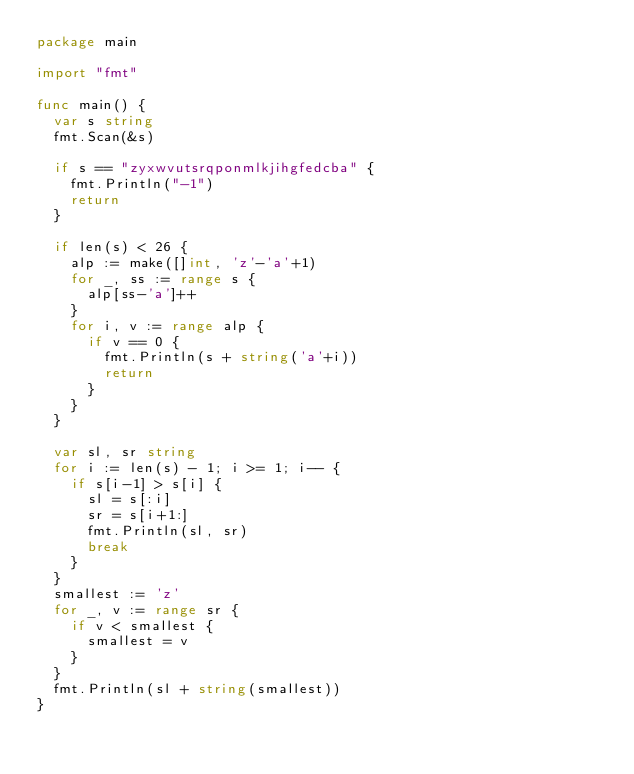Convert code to text. <code><loc_0><loc_0><loc_500><loc_500><_Go_>package main

import "fmt"

func main() {
	var s string
	fmt.Scan(&s)

	if s == "zyxwvutsrqponmlkjihgfedcba" {
		fmt.Println("-1")
		return
	}

	if len(s) < 26 {
		alp := make([]int, 'z'-'a'+1)
		for _, ss := range s {
			alp[ss-'a']++
		}
		for i, v := range alp {
			if v == 0 {
				fmt.Println(s + string('a'+i))
				return
			}
		}
	}

	var sl, sr string
	for i := len(s) - 1; i >= 1; i-- {
		if s[i-1] > s[i] {
			sl = s[:i]
			sr = s[i+1:]
			fmt.Println(sl, sr)
			break
		}
	}
	smallest := 'z'
	for _, v := range sr {
		if v < smallest {
			smallest = v
		}
	}
	fmt.Println(sl + string(smallest))
}
</code> 